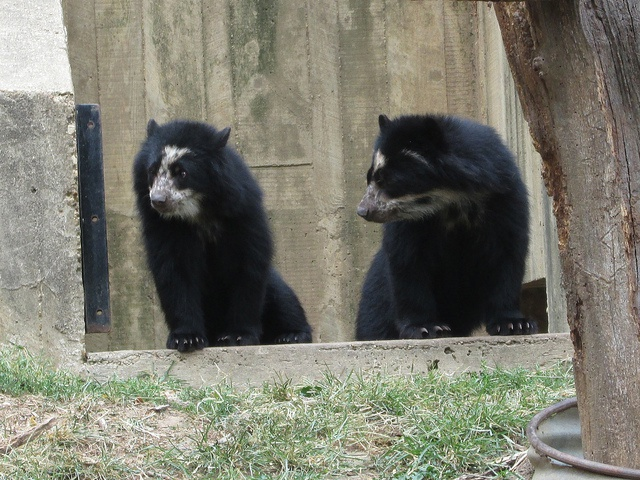Describe the objects in this image and their specific colors. I can see bear in lightgray, black, gray, and darkgray tones and bear in lightgray, black, gray, and darkgray tones in this image. 